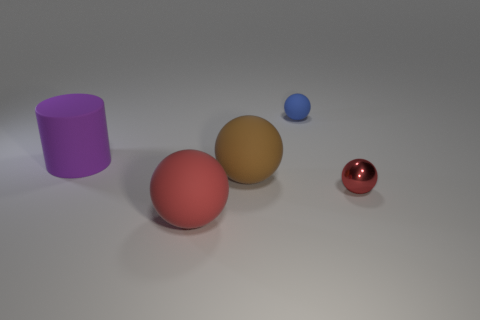What is the size of the red ball that is to the right of the small thing that is behind the small object that is on the right side of the blue ball?
Your response must be concise. Small. What is the shape of the rubber thing that is behind the large brown rubber sphere and in front of the blue thing?
Make the answer very short. Cylinder. Are there an equal number of red balls that are to the right of the small red shiny sphere and brown balls to the right of the small blue matte ball?
Give a very brief answer. Yes. Is there a large purple thing that has the same material as the big brown ball?
Provide a succinct answer. Yes. Is the material of the object that is behind the large purple matte object the same as the large purple thing?
Your answer should be very brief. Yes. There is a object that is on the right side of the brown rubber thing and in front of the large brown matte ball; how big is it?
Give a very brief answer. Small. What is the color of the tiny matte object?
Ensure brevity in your answer.  Blue. What number of large yellow metal objects are there?
Provide a succinct answer. 0. How many other large spheres have the same color as the metallic ball?
Ensure brevity in your answer.  1. There is a small object behind the brown sphere; is it the same shape as the red object that is on the right side of the blue matte ball?
Provide a succinct answer. Yes. 